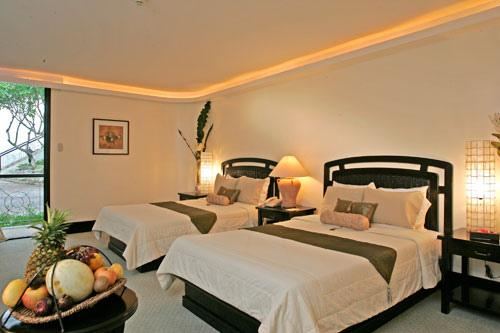What is the most likely level of this room?

Choices:
A) basement
B) ground
C) penthouse
D) third ground 